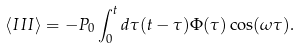<formula> <loc_0><loc_0><loc_500><loc_500>\left \langle I I I \right \rangle = - P _ { 0 } \int _ { 0 } ^ { t } d \tau ( t - \tau ) \Phi ( \tau ) \cos ( \omega \tau ) .</formula> 